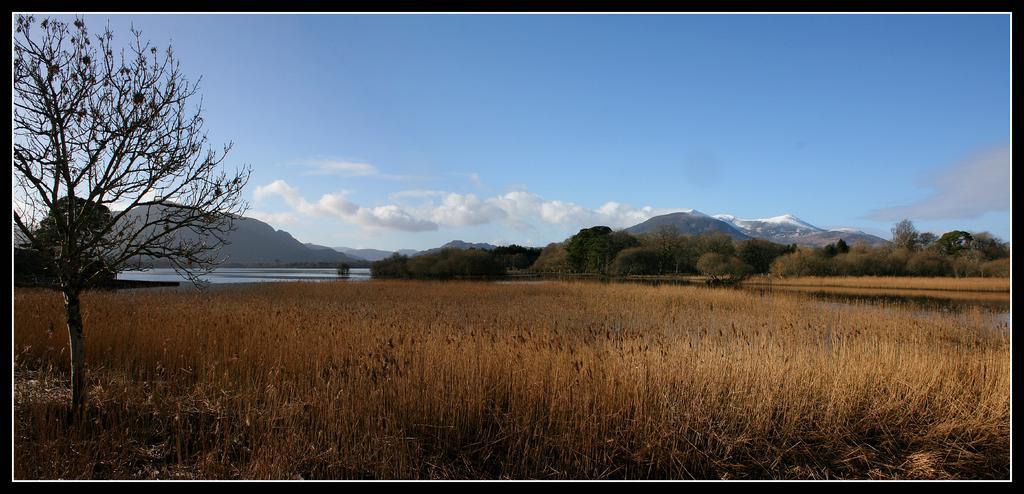Could you give a brief overview of what you see in this image? In the picture we can see grass, trees, water, and mountains. In the background there is sky with clouds. 